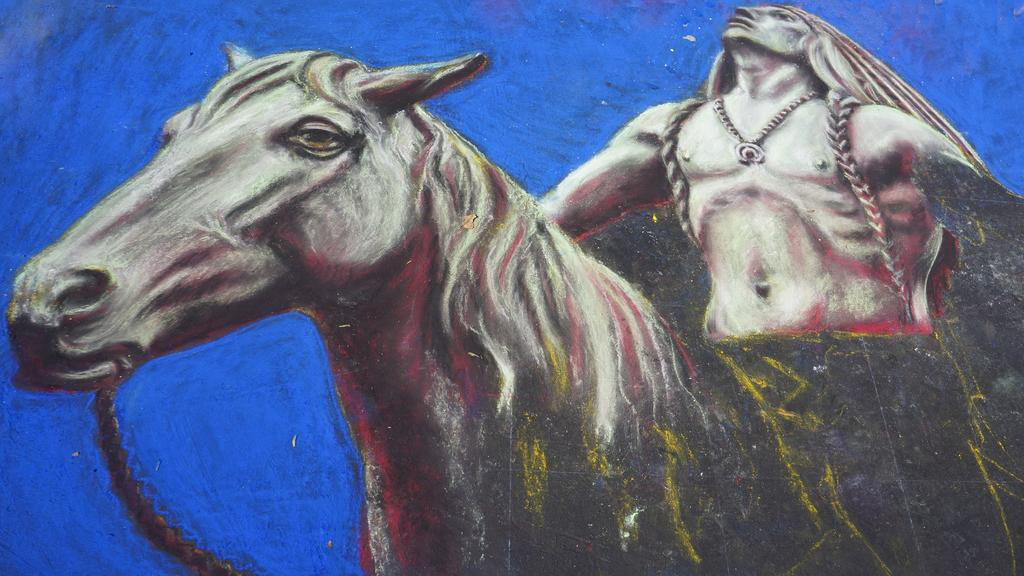What type of artwork is depicted in the image? The image is a painting. Can you describe the subject matter of the painting? There is a person in the painting. What is the person doing in the painting? The person is on a horse. Where is the bee's nest located in the painting? There is no bee or nest present in the painting; it features a person on a horse. Can you describe the toad's behavior in the painting? There is no toad present in the painting; it features a person on a horse. 